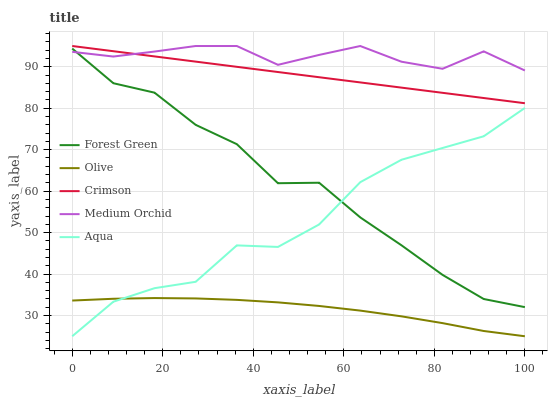Does Crimson have the minimum area under the curve?
Answer yes or no. No. Does Crimson have the maximum area under the curve?
Answer yes or no. No. Is Forest Green the smoothest?
Answer yes or no. No. Is Forest Green the roughest?
Answer yes or no. No. Does Crimson have the lowest value?
Answer yes or no. No. Does Forest Green have the highest value?
Answer yes or no. No. Is Olive less than Forest Green?
Answer yes or no. Yes. Is Forest Green greater than Olive?
Answer yes or no. Yes. Does Olive intersect Forest Green?
Answer yes or no. No. 